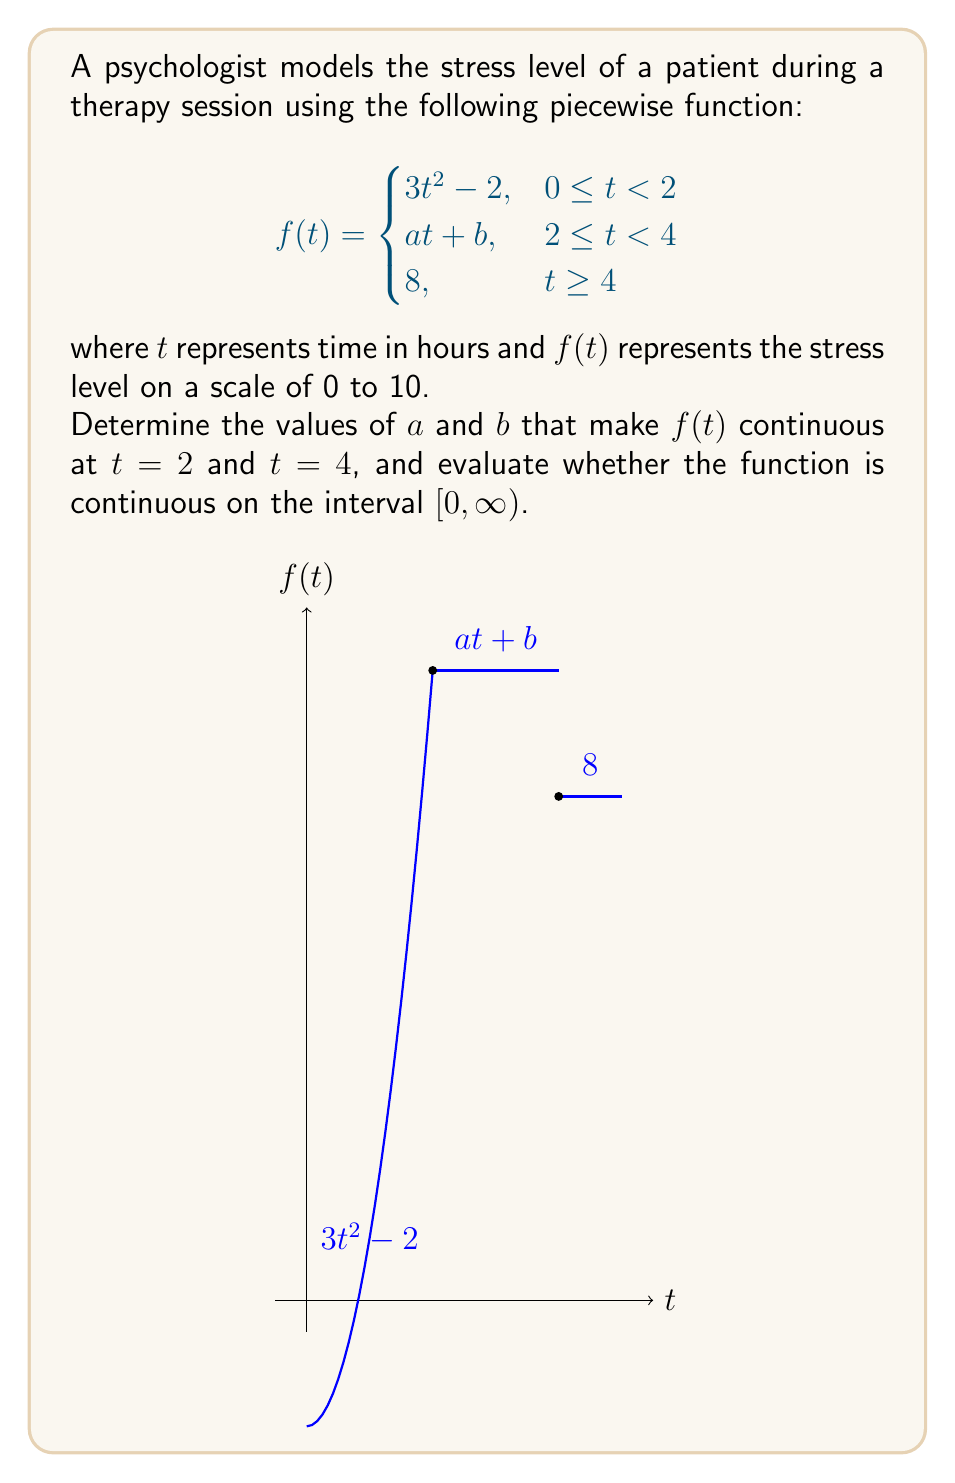Provide a solution to this math problem. To determine the continuity of $f(t)$, we need to check for continuity at the points where the function changes its definition: $t = 2$ and $t = 4$.

1. Continuity at $t = 2$:
   For $f(t)$ to be continuous at $t = 2$, the limit as $t$ approaches 2 from both sides must exist and be equal to $f(2)$.
   
   Left-hand limit: $\lim_{t \to 2^-} f(t) = 3(2)^2 - 2 = 10$
   Right-hand limit: $\lim_{t \to 2^+} f(t) = a(2) + b = 2a + b$
   
   For continuity: $3(2)^2 - 2 = 2a + b$
   $10 = 2a + b$ ... (Equation 1)

2. Continuity at $t = 4$:
   Left-hand limit: $\lim_{t \to 4^-} f(t) = a(4) + b = 4a + b$
   Right-hand limit: $\lim_{t \to 4^+} f(t) = 8$
   
   For continuity: $4a + b = 8$ ... (Equation 2)

3. Solving for $a$ and $b$:
   Subtracting Equation 1 from Equation 2:
   $(4a + b) - (2a + b) = 8 - 10$
   $2a = -2$
   $a = -1$

   Substituting $a = -1$ into Equation 1:
   $10 = 2(-1) + b$
   $10 = -2 + b$
   $b = 12$

4. Checking continuity on $[0, \infty)$:
   - The function is continuous on $[0, 2)$ as it's a polynomial.
   - It's continuous at $t = 2$ because we found $a$ and $b$ to make it continuous.
   - It's continuous on $(2, 4)$ as it's a linear function.
   - It's continuous at $t = 4$ because we found $a$ and $b$ to make it continuous.
   - It's continuous on $(4, \infty)$ as it's a constant function.

Therefore, $f(t)$ is continuous on $[0, \infty)$ when $a = -1$ and $b = 12$.
Answer: $a = -1$, $b = 12$; $f(t)$ is continuous on $[0, \infty)$. 